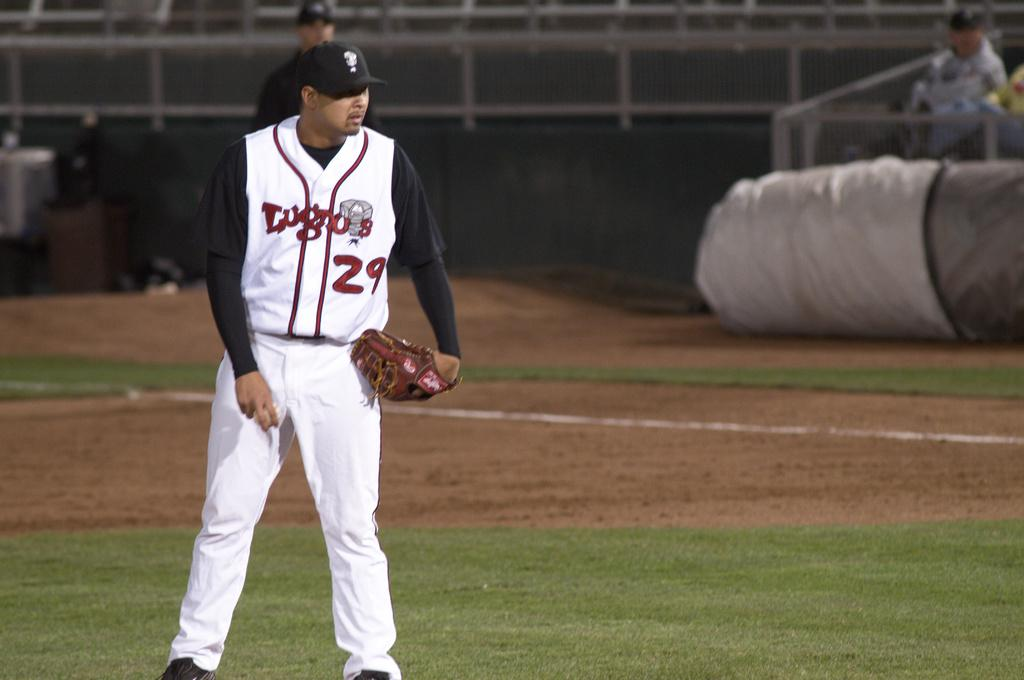How many players are in the image? There are two players in the image. Where are the players located? The players are on a ground. What can be seen in the background of the image? There is a pole and two persons sitting on chairs in the background of the image. What type of dinosaurs can be seen in the image? There are no dinosaurs present in the image. What letters are visible on the players' uniforms in the image? The provided facts do not mention any letters on the players' uniforms, so we cannot determine if any letters are visible. 